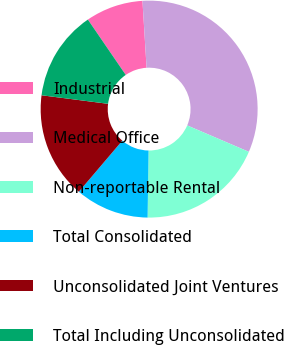Convert chart to OTSL. <chart><loc_0><loc_0><loc_500><loc_500><pie_chart><fcel>Industrial<fcel>Medical Office<fcel>Non-reportable Rental<fcel>Total Consolidated<fcel>Unconsolidated Joint Ventures<fcel>Total Including Unconsolidated<nl><fcel>8.57%<fcel>32.42%<fcel>18.78%<fcel>10.99%<fcel>15.82%<fcel>13.41%<nl></chart> 